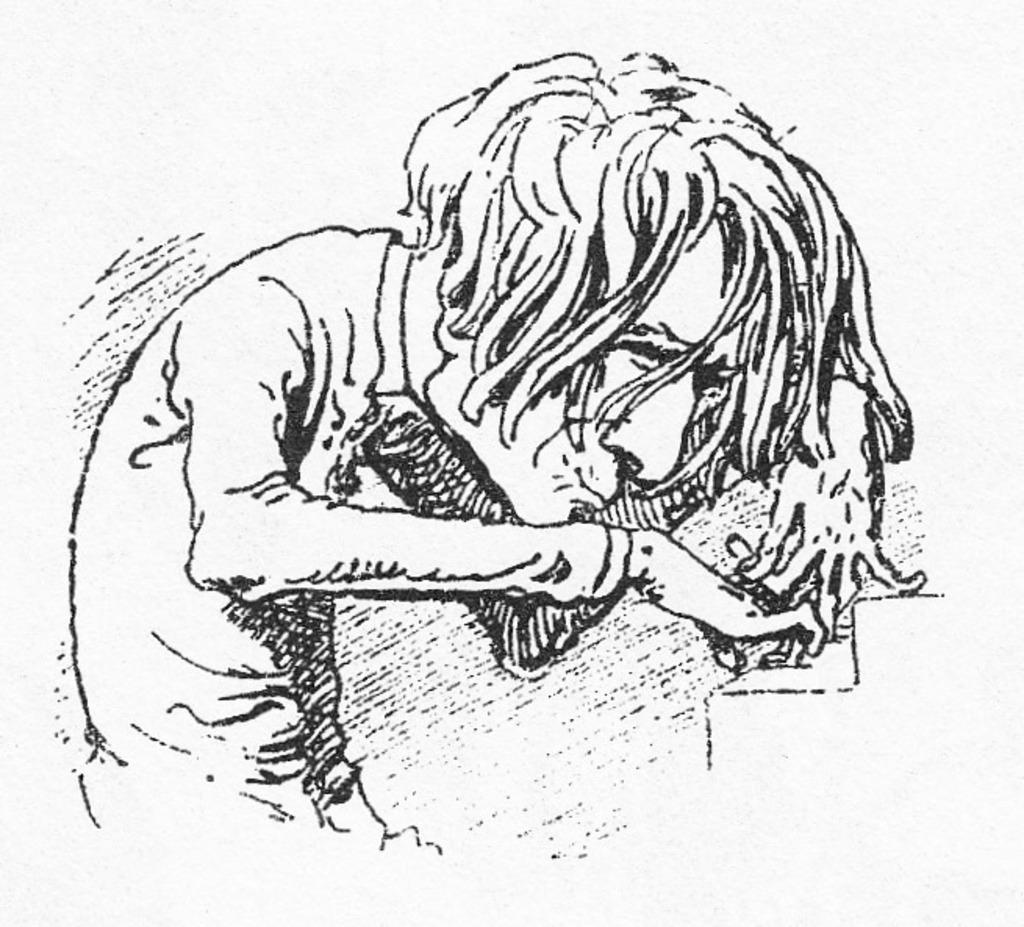Can you describe this image briefly? This image consists of a poster with an art on it. 